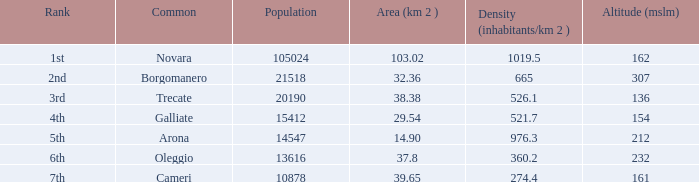What is the minimum height (mslm) in all the commons? 136.0. 